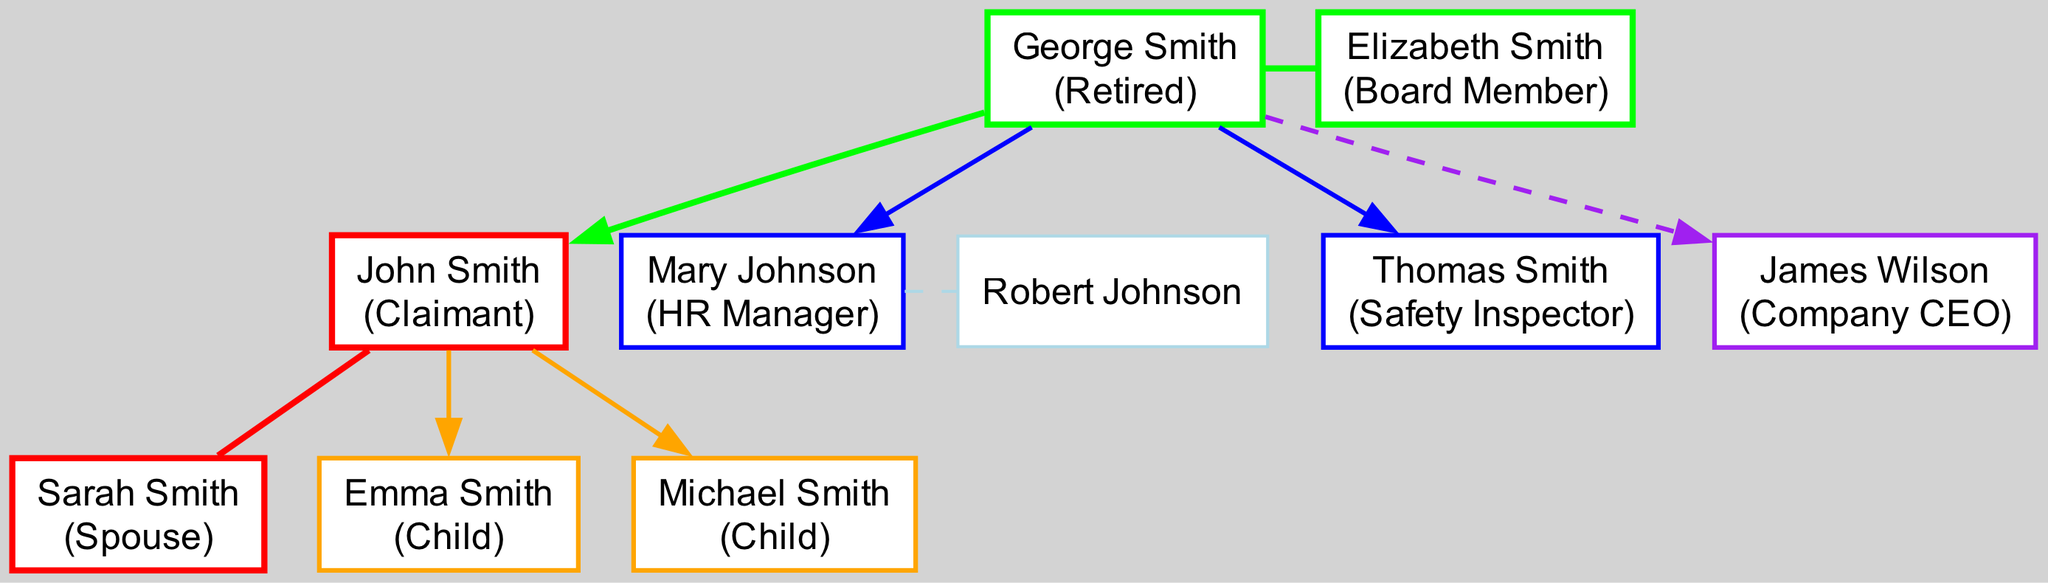What is the name of the claimant? The claimant's name appears prominently at the top of the diagram, labeled as "John Smith".
Answer: John Smith Who is the spouse of the claimant? The diagram shows a direct connection between the claimant, John Smith, and his spouse, Sarah Smith, indicated by a connecting edge.
Answer: Sarah Smith How many children does the claimant have? The diagram lists two children under the claimant, Emma Smith and Michael Smith, representing the count of nodes linked to the claimant's position.
Answer: 2 What is the role of the claimant's sibling, Mary Johnson? The node for Mary Johnson is labeled with her role, which is shown alongside her name in the diagram as "HR Manager".
Answer: HR Manager What is the relationship between John Smith and James Wilson? The diagram indicates that James Wilson is the uncle of John Smith, as shown through a dashed edge connecting them via their parents.
Answer: Uncle How many siblings does the claimant have? The diagram indicates there are two siblings listed for the claimant: Mary Johnson and Thomas Smith, connecting to the same parent node.
Answer: 2 Which family member is a Board Member? The diagram clearly identifies Elizabeth Smith as a Board Member, marking her in the parents' section of the tree.
Answer: Elizabeth Smith Which role does John Smith's brother, Thomas Smith, hold? The node for Thomas Smith specifies his role directly in the diagram, showing it is "Safety Inspector".
Answer: Safety Inspector Who is the CEO of the company? The diagram features James Wilson, indicated to be the Company CEO in his node, which connects him to the claimant’s family tree.
Answer: James Wilson How is Sarah Smith related to John Smith? The diagram shows a direct link between John Smith and Sarah Smith labeled as spouses, indicating their marital relationship.
Answer: Spouse 